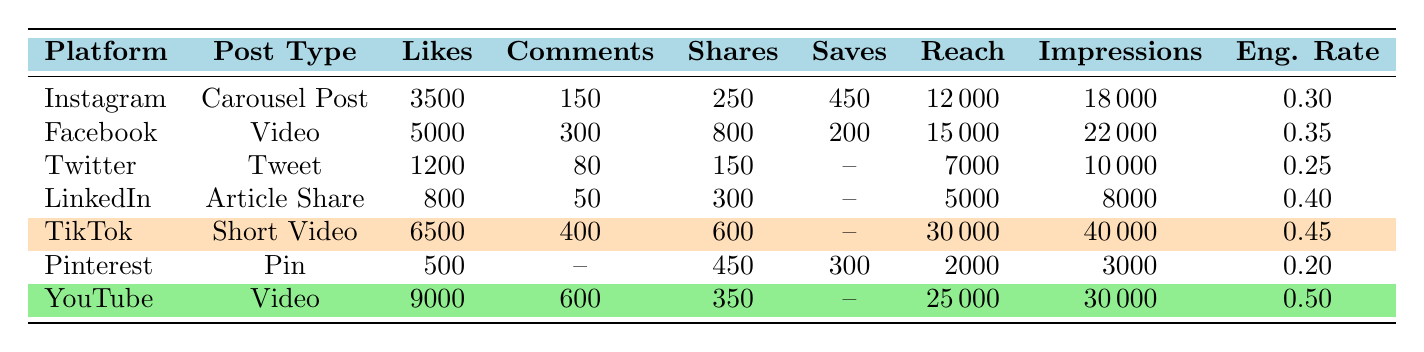What is the platform with the highest engagement rate? Looking at the engagement rates in the table, TikTok has an engagement rate of 0.45 and YouTube has an engagement rate of 0.50. YouTube has the highest engagement rate among all platforms.
Answer: YouTube How many likes did the TikTok post receive? The table shows that the TikTok post received 6500 likes.
Answer: 6500 Which platform had the most reach? Comparing the reach values, TikTok shows a reach of 30,000, which is the highest among all listed platforms.
Answer: TikTok What is the total number of likes across all platforms? The total is calculated by adding the likes: 3500 (Instagram) + 5000 (Facebook) + 1200 (Twitter) + 800 (LinkedIn) + 6500 (TikTok) + 500 (Pinterest) + 9000 (YouTube) = 25,500.
Answer: 25500 Did Pinterest receive more comments than Twitter? The comments for Pinterest are not listed, and Twitter received 80 comments. Since we don't know Pinterest's value, we cannot determine this.
Answer: No Which platform showed a higher number of shares, Facebook or YouTube? Facebook received 800 shares while YouTube received 350 shares. Since 800 is greater than 350, Facebook had more shares.
Answer: Facebook What percentage of the total impressions came from YouTube? To find the total impressions, add all impressions: 18,000 (Instagram) + 22,000 (Facebook) + 10,000 (Twitter) + 8,000 (LinkedIn) + 40,000 (TikTok) + 3,000 (Pinterest) + 30,000 (YouTube) = 129,000. Then take YouTube's impressions: (30,000 / 129,000) * 100 ≈ 23.26%.
Answer: 23.26% What is the average engagement rate of all platforms? To calculate the average, add all engagement rates: 0.30 (Instagram) + 0.35 (Facebook) + 0.25 (Twitter) + 0.40 (LinkedIn) + 0.45 (TikTok) + 0.20 (Pinterest) + 0.50 (YouTube) = 2.45. Divide by the number of platforms (7): 2.45 / 7 ≈ 0.35.
Answer: 0.35 Which platform had more saves, Instagram or LinkedIn? Instagram had 450 saves, while LinkedIn had no listed saves. Therefore, Instagram had more saves.
Answer: Instagram What is the difference in reach between TikTok and Pinterest? TikTok had a reach of 30,000, and Pinterest had a reach of 2,000. The difference is 30,000 - 2,000 = 28,000.
Answer: 28000 